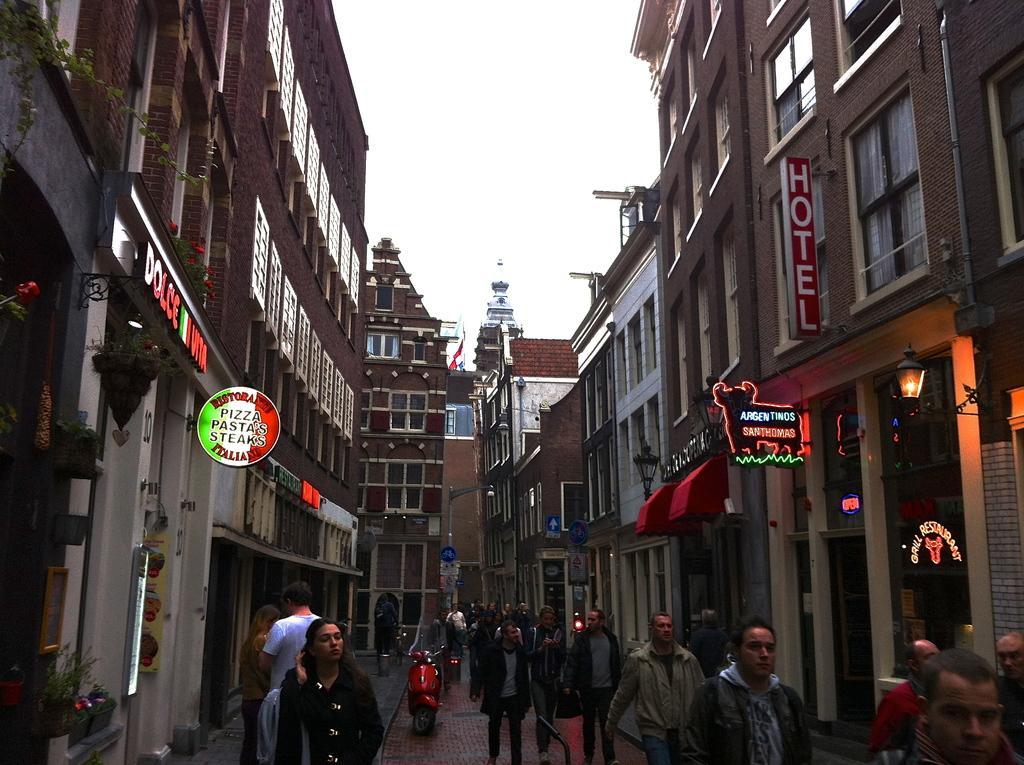Could you give a brief overview of what you see in this image? In this image there are buildings. At the bottom there are people and we can see a bike on the road. In the background there is sky. 